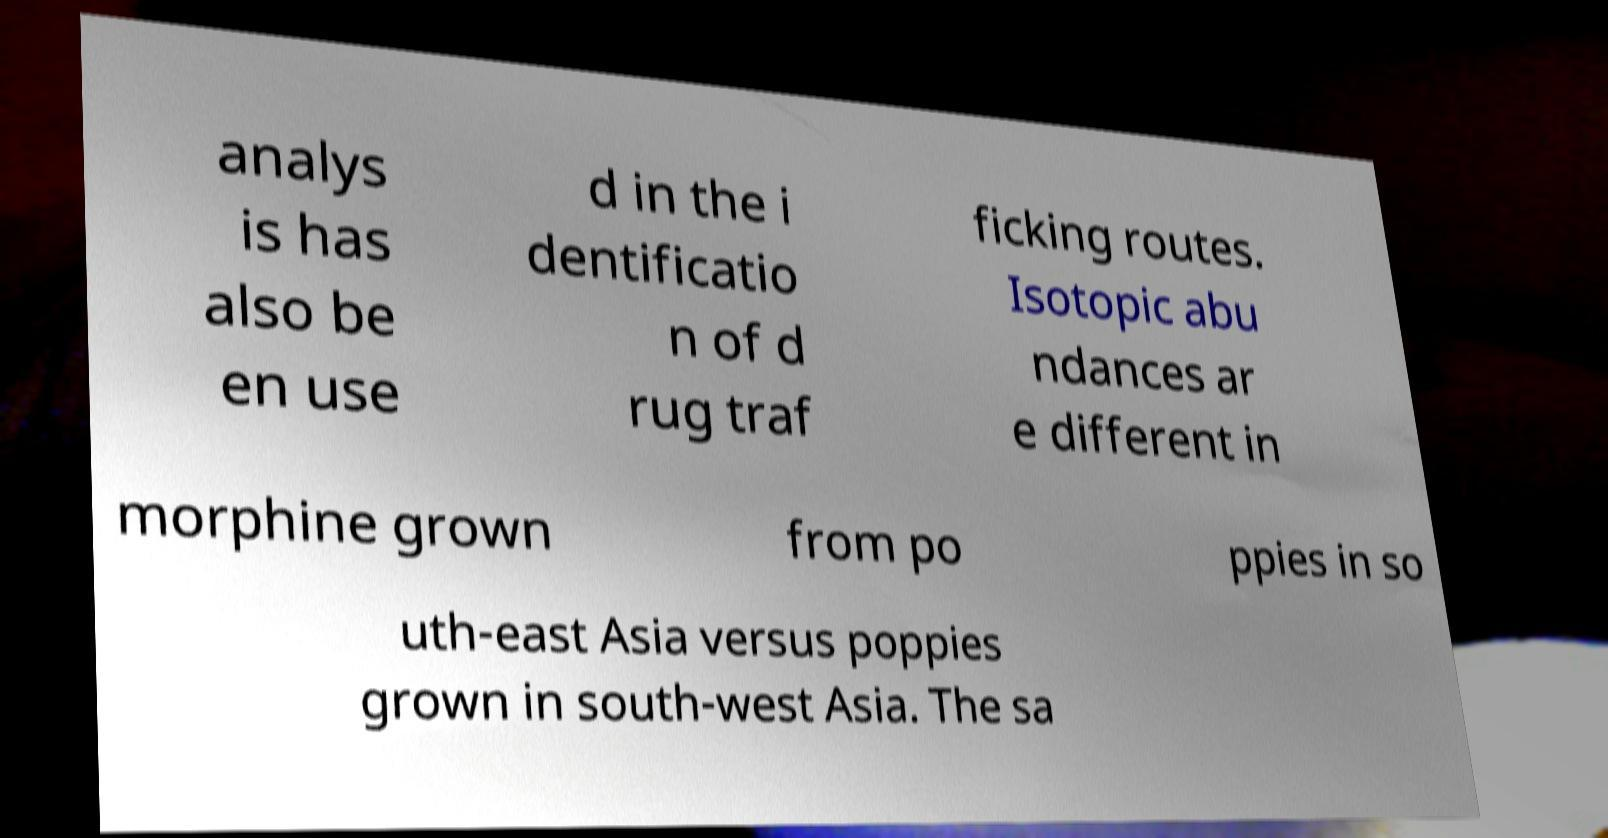Could you extract and type out the text from this image? analys is has also be en use d in the i dentificatio n of d rug traf ficking routes. Isotopic abu ndances ar e different in morphine grown from po ppies in so uth-east Asia versus poppies grown in south-west Asia. The sa 